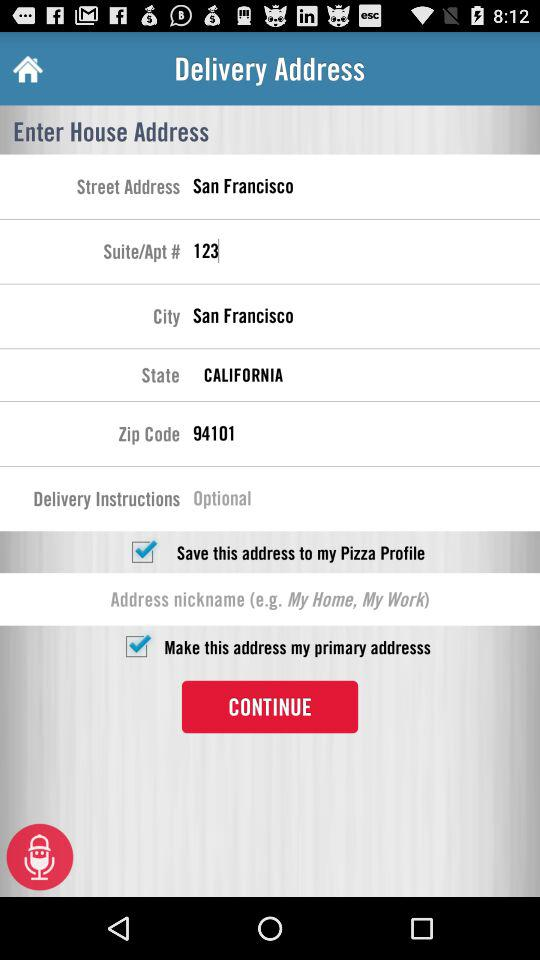What is the state? The state is California. 